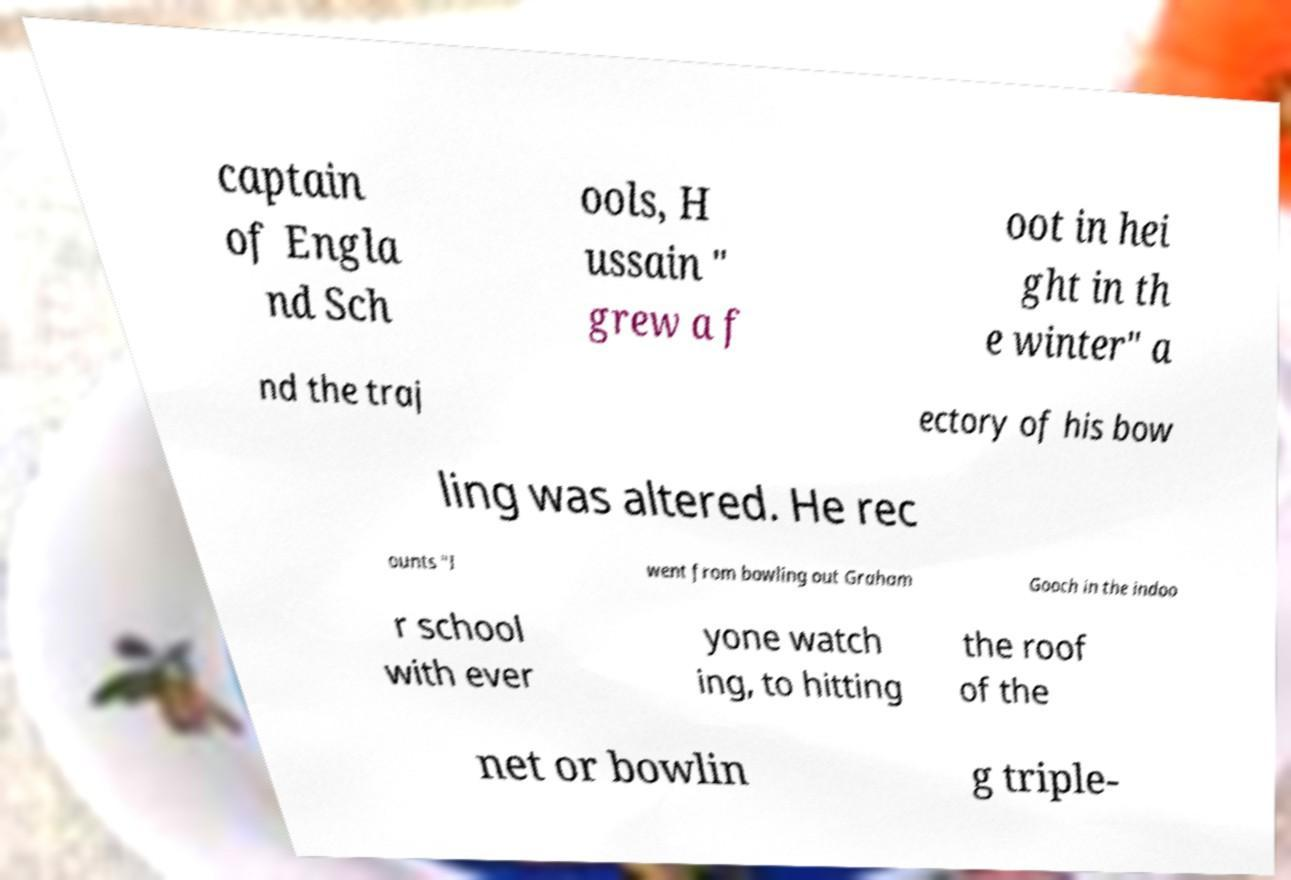Could you assist in decoding the text presented in this image and type it out clearly? captain of Engla nd Sch ools, H ussain " grew a f oot in hei ght in th e winter" a nd the traj ectory of his bow ling was altered. He rec ounts "I went from bowling out Graham Gooch in the indoo r school with ever yone watch ing, to hitting the roof of the net or bowlin g triple- 